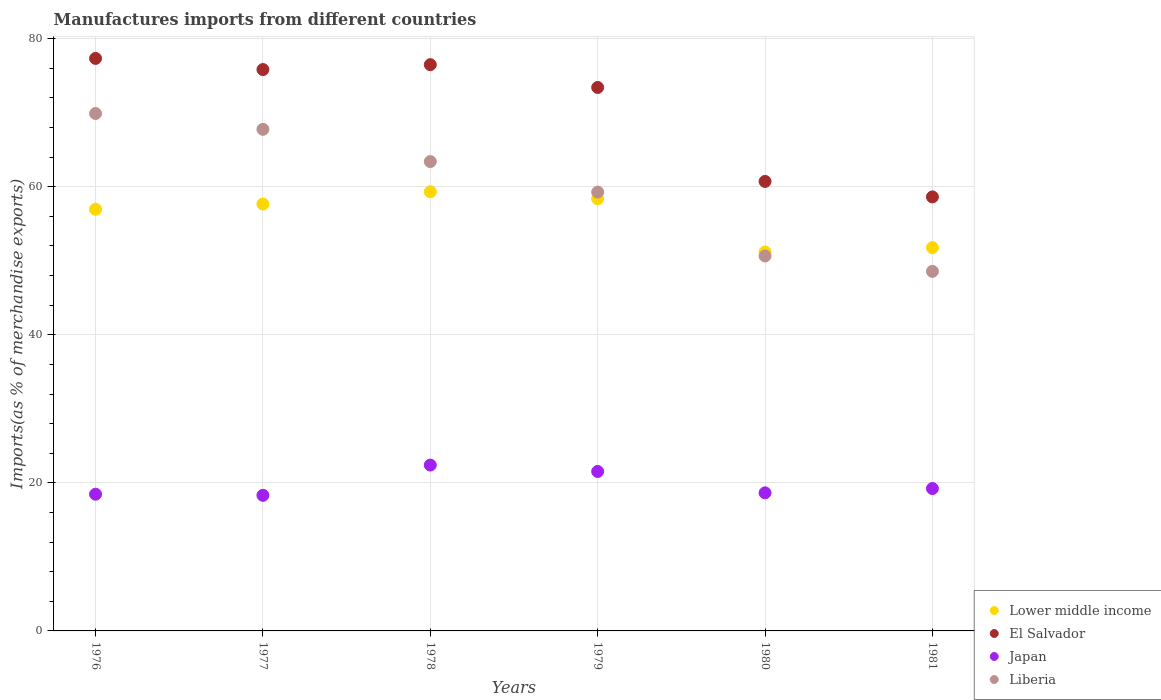How many different coloured dotlines are there?
Ensure brevity in your answer.  4. Is the number of dotlines equal to the number of legend labels?
Your response must be concise. Yes. What is the percentage of imports to different countries in Japan in 1979?
Your answer should be compact. 21.54. Across all years, what is the maximum percentage of imports to different countries in Lower middle income?
Your answer should be very brief. 59.32. Across all years, what is the minimum percentage of imports to different countries in Japan?
Provide a succinct answer. 18.32. In which year was the percentage of imports to different countries in Liberia maximum?
Make the answer very short. 1976. What is the total percentage of imports to different countries in Japan in the graph?
Offer a very short reply. 118.61. What is the difference between the percentage of imports to different countries in Japan in 1978 and that in 1981?
Provide a succinct answer. 3.17. What is the difference between the percentage of imports to different countries in El Salvador in 1981 and the percentage of imports to different countries in Liberia in 1976?
Your answer should be very brief. -11.27. What is the average percentage of imports to different countries in Lower middle income per year?
Ensure brevity in your answer.  55.88. In the year 1980, what is the difference between the percentage of imports to different countries in El Salvador and percentage of imports to different countries in Lower middle income?
Your answer should be very brief. 9.53. In how many years, is the percentage of imports to different countries in El Salvador greater than 36 %?
Keep it short and to the point. 6. What is the ratio of the percentage of imports to different countries in Lower middle income in 1976 to that in 1978?
Your response must be concise. 0.96. Is the percentage of imports to different countries in Liberia in 1979 less than that in 1981?
Offer a very short reply. No. What is the difference between the highest and the second highest percentage of imports to different countries in El Salvador?
Your answer should be compact. 0.84. What is the difference between the highest and the lowest percentage of imports to different countries in El Salvador?
Offer a very short reply. 18.71. Is the sum of the percentage of imports to different countries in Japan in 1976 and 1978 greater than the maximum percentage of imports to different countries in Lower middle income across all years?
Your answer should be very brief. No. Does the percentage of imports to different countries in El Salvador monotonically increase over the years?
Make the answer very short. No. How many dotlines are there?
Your answer should be very brief. 4. How many years are there in the graph?
Provide a short and direct response. 6. What is the difference between two consecutive major ticks on the Y-axis?
Provide a succinct answer. 20. Does the graph contain any zero values?
Provide a short and direct response. No. Where does the legend appear in the graph?
Give a very brief answer. Bottom right. How many legend labels are there?
Offer a very short reply. 4. How are the legend labels stacked?
Keep it short and to the point. Vertical. What is the title of the graph?
Your answer should be very brief. Manufactures imports from different countries. Does "St. Martin (French part)" appear as one of the legend labels in the graph?
Offer a very short reply. No. What is the label or title of the X-axis?
Offer a terse response. Years. What is the label or title of the Y-axis?
Your answer should be very brief. Imports(as % of merchandise exports). What is the Imports(as % of merchandise exports) of Lower middle income in 1976?
Your answer should be very brief. 56.96. What is the Imports(as % of merchandise exports) in El Salvador in 1976?
Make the answer very short. 77.33. What is the Imports(as % of merchandise exports) in Japan in 1976?
Keep it short and to the point. 18.47. What is the Imports(as % of merchandise exports) in Liberia in 1976?
Your answer should be very brief. 69.89. What is the Imports(as % of merchandise exports) of Lower middle income in 1977?
Your response must be concise. 57.66. What is the Imports(as % of merchandise exports) in El Salvador in 1977?
Your answer should be compact. 75.83. What is the Imports(as % of merchandise exports) in Japan in 1977?
Provide a succinct answer. 18.32. What is the Imports(as % of merchandise exports) in Liberia in 1977?
Your answer should be very brief. 67.76. What is the Imports(as % of merchandise exports) in Lower middle income in 1978?
Offer a very short reply. 59.32. What is the Imports(as % of merchandise exports) in El Salvador in 1978?
Provide a succinct answer. 76.49. What is the Imports(as % of merchandise exports) in Japan in 1978?
Provide a short and direct response. 22.4. What is the Imports(as % of merchandise exports) of Liberia in 1978?
Provide a succinct answer. 63.4. What is the Imports(as % of merchandise exports) in Lower middle income in 1979?
Keep it short and to the point. 58.38. What is the Imports(as % of merchandise exports) in El Salvador in 1979?
Provide a succinct answer. 73.41. What is the Imports(as % of merchandise exports) of Japan in 1979?
Provide a short and direct response. 21.54. What is the Imports(as % of merchandise exports) of Liberia in 1979?
Offer a very short reply. 59.27. What is the Imports(as % of merchandise exports) of Lower middle income in 1980?
Offer a terse response. 51.19. What is the Imports(as % of merchandise exports) in El Salvador in 1980?
Offer a very short reply. 60.72. What is the Imports(as % of merchandise exports) of Japan in 1980?
Make the answer very short. 18.65. What is the Imports(as % of merchandise exports) of Liberia in 1980?
Your answer should be very brief. 50.65. What is the Imports(as % of merchandise exports) in Lower middle income in 1981?
Offer a terse response. 51.77. What is the Imports(as % of merchandise exports) of El Salvador in 1981?
Offer a very short reply. 58.63. What is the Imports(as % of merchandise exports) in Japan in 1981?
Offer a very short reply. 19.23. What is the Imports(as % of merchandise exports) of Liberia in 1981?
Offer a terse response. 48.57. Across all years, what is the maximum Imports(as % of merchandise exports) of Lower middle income?
Provide a succinct answer. 59.32. Across all years, what is the maximum Imports(as % of merchandise exports) in El Salvador?
Make the answer very short. 77.33. Across all years, what is the maximum Imports(as % of merchandise exports) of Japan?
Your response must be concise. 22.4. Across all years, what is the maximum Imports(as % of merchandise exports) of Liberia?
Offer a terse response. 69.89. Across all years, what is the minimum Imports(as % of merchandise exports) in Lower middle income?
Provide a succinct answer. 51.19. Across all years, what is the minimum Imports(as % of merchandise exports) of El Salvador?
Your answer should be very brief. 58.63. Across all years, what is the minimum Imports(as % of merchandise exports) of Japan?
Your response must be concise. 18.32. Across all years, what is the minimum Imports(as % of merchandise exports) of Liberia?
Offer a very short reply. 48.57. What is the total Imports(as % of merchandise exports) in Lower middle income in the graph?
Offer a very short reply. 335.28. What is the total Imports(as % of merchandise exports) of El Salvador in the graph?
Your response must be concise. 422.4. What is the total Imports(as % of merchandise exports) of Japan in the graph?
Provide a short and direct response. 118.61. What is the total Imports(as % of merchandise exports) of Liberia in the graph?
Your answer should be compact. 359.54. What is the difference between the Imports(as % of merchandise exports) in Lower middle income in 1976 and that in 1977?
Make the answer very short. -0.7. What is the difference between the Imports(as % of merchandise exports) in El Salvador in 1976 and that in 1977?
Provide a short and direct response. 1.5. What is the difference between the Imports(as % of merchandise exports) of Japan in 1976 and that in 1977?
Keep it short and to the point. 0.15. What is the difference between the Imports(as % of merchandise exports) of Liberia in 1976 and that in 1977?
Your answer should be very brief. 2.14. What is the difference between the Imports(as % of merchandise exports) of Lower middle income in 1976 and that in 1978?
Make the answer very short. -2.36. What is the difference between the Imports(as % of merchandise exports) in El Salvador in 1976 and that in 1978?
Give a very brief answer. 0.84. What is the difference between the Imports(as % of merchandise exports) of Japan in 1976 and that in 1978?
Ensure brevity in your answer.  -3.94. What is the difference between the Imports(as % of merchandise exports) of Liberia in 1976 and that in 1978?
Ensure brevity in your answer.  6.49. What is the difference between the Imports(as % of merchandise exports) in Lower middle income in 1976 and that in 1979?
Keep it short and to the point. -1.42. What is the difference between the Imports(as % of merchandise exports) in El Salvador in 1976 and that in 1979?
Your response must be concise. 3.92. What is the difference between the Imports(as % of merchandise exports) of Japan in 1976 and that in 1979?
Offer a very short reply. -3.07. What is the difference between the Imports(as % of merchandise exports) in Liberia in 1976 and that in 1979?
Your answer should be very brief. 10.62. What is the difference between the Imports(as % of merchandise exports) of Lower middle income in 1976 and that in 1980?
Your response must be concise. 5.77. What is the difference between the Imports(as % of merchandise exports) of El Salvador in 1976 and that in 1980?
Ensure brevity in your answer.  16.62. What is the difference between the Imports(as % of merchandise exports) in Japan in 1976 and that in 1980?
Offer a terse response. -0.19. What is the difference between the Imports(as % of merchandise exports) in Liberia in 1976 and that in 1980?
Your answer should be very brief. 19.25. What is the difference between the Imports(as % of merchandise exports) of Lower middle income in 1976 and that in 1981?
Offer a terse response. 5.18. What is the difference between the Imports(as % of merchandise exports) in El Salvador in 1976 and that in 1981?
Offer a terse response. 18.71. What is the difference between the Imports(as % of merchandise exports) of Japan in 1976 and that in 1981?
Keep it short and to the point. -0.77. What is the difference between the Imports(as % of merchandise exports) of Liberia in 1976 and that in 1981?
Your answer should be very brief. 21.32. What is the difference between the Imports(as % of merchandise exports) of Lower middle income in 1977 and that in 1978?
Your answer should be very brief. -1.66. What is the difference between the Imports(as % of merchandise exports) of El Salvador in 1977 and that in 1978?
Your answer should be very brief. -0.66. What is the difference between the Imports(as % of merchandise exports) in Japan in 1977 and that in 1978?
Ensure brevity in your answer.  -4.09. What is the difference between the Imports(as % of merchandise exports) in Liberia in 1977 and that in 1978?
Your answer should be very brief. 4.35. What is the difference between the Imports(as % of merchandise exports) in Lower middle income in 1977 and that in 1979?
Ensure brevity in your answer.  -0.72. What is the difference between the Imports(as % of merchandise exports) in El Salvador in 1977 and that in 1979?
Provide a succinct answer. 2.42. What is the difference between the Imports(as % of merchandise exports) in Japan in 1977 and that in 1979?
Your answer should be very brief. -3.22. What is the difference between the Imports(as % of merchandise exports) in Liberia in 1977 and that in 1979?
Offer a very short reply. 8.48. What is the difference between the Imports(as % of merchandise exports) of Lower middle income in 1977 and that in 1980?
Provide a succinct answer. 6.48. What is the difference between the Imports(as % of merchandise exports) in El Salvador in 1977 and that in 1980?
Your response must be concise. 15.11. What is the difference between the Imports(as % of merchandise exports) of Japan in 1977 and that in 1980?
Your response must be concise. -0.34. What is the difference between the Imports(as % of merchandise exports) in Liberia in 1977 and that in 1980?
Your response must be concise. 17.11. What is the difference between the Imports(as % of merchandise exports) of Lower middle income in 1977 and that in 1981?
Give a very brief answer. 5.89. What is the difference between the Imports(as % of merchandise exports) in El Salvador in 1977 and that in 1981?
Provide a short and direct response. 17.2. What is the difference between the Imports(as % of merchandise exports) in Japan in 1977 and that in 1981?
Your answer should be very brief. -0.92. What is the difference between the Imports(as % of merchandise exports) in Liberia in 1977 and that in 1981?
Offer a very short reply. 19.19. What is the difference between the Imports(as % of merchandise exports) in Lower middle income in 1978 and that in 1979?
Offer a very short reply. 0.94. What is the difference between the Imports(as % of merchandise exports) in El Salvador in 1978 and that in 1979?
Keep it short and to the point. 3.08. What is the difference between the Imports(as % of merchandise exports) in Japan in 1978 and that in 1979?
Provide a succinct answer. 0.86. What is the difference between the Imports(as % of merchandise exports) in Liberia in 1978 and that in 1979?
Your answer should be compact. 4.13. What is the difference between the Imports(as % of merchandise exports) of Lower middle income in 1978 and that in 1980?
Keep it short and to the point. 8.13. What is the difference between the Imports(as % of merchandise exports) of El Salvador in 1978 and that in 1980?
Your answer should be compact. 15.77. What is the difference between the Imports(as % of merchandise exports) of Japan in 1978 and that in 1980?
Ensure brevity in your answer.  3.75. What is the difference between the Imports(as % of merchandise exports) in Liberia in 1978 and that in 1980?
Your answer should be compact. 12.76. What is the difference between the Imports(as % of merchandise exports) in Lower middle income in 1978 and that in 1981?
Ensure brevity in your answer.  7.55. What is the difference between the Imports(as % of merchandise exports) of El Salvador in 1978 and that in 1981?
Give a very brief answer. 17.86. What is the difference between the Imports(as % of merchandise exports) of Japan in 1978 and that in 1981?
Ensure brevity in your answer.  3.17. What is the difference between the Imports(as % of merchandise exports) in Liberia in 1978 and that in 1981?
Provide a short and direct response. 14.83. What is the difference between the Imports(as % of merchandise exports) of Lower middle income in 1979 and that in 1980?
Provide a short and direct response. 7.19. What is the difference between the Imports(as % of merchandise exports) in El Salvador in 1979 and that in 1980?
Your response must be concise. 12.69. What is the difference between the Imports(as % of merchandise exports) of Japan in 1979 and that in 1980?
Ensure brevity in your answer.  2.89. What is the difference between the Imports(as % of merchandise exports) of Liberia in 1979 and that in 1980?
Your response must be concise. 8.63. What is the difference between the Imports(as % of merchandise exports) in Lower middle income in 1979 and that in 1981?
Make the answer very short. 6.6. What is the difference between the Imports(as % of merchandise exports) of El Salvador in 1979 and that in 1981?
Offer a very short reply. 14.78. What is the difference between the Imports(as % of merchandise exports) in Japan in 1979 and that in 1981?
Make the answer very short. 2.31. What is the difference between the Imports(as % of merchandise exports) of Liberia in 1979 and that in 1981?
Make the answer very short. 10.7. What is the difference between the Imports(as % of merchandise exports) of Lower middle income in 1980 and that in 1981?
Provide a short and direct response. -0.59. What is the difference between the Imports(as % of merchandise exports) of El Salvador in 1980 and that in 1981?
Provide a short and direct response. 2.09. What is the difference between the Imports(as % of merchandise exports) in Japan in 1980 and that in 1981?
Ensure brevity in your answer.  -0.58. What is the difference between the Imports(as % of merchandise exports) of Liberia in 1980 and that in 1981?
Provide a succinct answer. 2.08. What is the difference between the Imports(as % of merchandise exports) of Lower middle income in 1976 and the Imports(as % of merchandise exports) of El Salvador in 1977?
Provide a short and direct response. -18.87. What is the difference between the Imports(as % of merchandise exports) in Lower middle income in 1976 and the Imports(as % of merchandise exports) in Japan in 1977?
Make the answer very short. 38.64. What is the difference between the Imports(as % of merchandise exports) in Lower middle income in 1976 and the Imports(as % of merchandise exports) in Liberia in 1977?
Ensure brevity in your answer.  -10.8. What is the difference between the Imports(as % of merchandise exports) of El Salvador in 1976 and the Imports(as % of merchandise exports) of Japan in 1977?
Keep it short and to the point. 59.02. What is the difference between the Imports(as % of merchandise exports) of El Salvador in 1976 and the Imports(as % of merchandise exports) of Liberia in 1977?
Ensure brevity in your answer.  9.58. What is the difference between the Imports(as % of merchandise exports) in Japan in 1976 and the Imports(as % of merchandise exports) in Liberia in 1977?
Ensure brevity in your answer.  -49.29. What is the difference between the Imports(as % of merchandise exports) of Lower middle income in 1976 and the Imports(as % of merchandise exports) of El Salvador in 1978?
Your response must be concise. -19.53. What is the difference between the Imports(as % of merchandise exports) in Lower middle income in 1976 and the Imports(as % of merchandise exports) in Japan in 1978?
Give a very brief answer. 34.56. What is the difference between the Imports(as % of merchandise exports) of Lower middle income in 1976 and the Imports(as % of merchandise exports) of Liberia in 1978?
Offer a terse response. -6.44. What is the difference between the Imports(as % of merchandise exports) of El Salvador in 1976 and the Imports(as % of merchandise exports) of Japan in 1978?
Your answer should be compact. 54.93. What is the difference between the Imports(as % of merchandise exports) of El Salvador in 1976 and the Imports(as % of merchandise exports) of Liberia in 1978?
Your answer should be compact. 13.93. What is the difference between the Imports(as % of merchandise exports) in Japan in 1976 and the Imports(as % of merchandise exports) in Liberia in 1978?
Your response must be concise. -44.94. What is the difference between the Imports(as % of merchandise exports) in Lower middle income in 1976 and the Imports(as % of merchandise exports) in El Salvador in 1979?
Give a very brief answer. -16.45. What is the difference between the Imports(as % of merchandise exports) in Lower middle income in 1976 and the Imports(as % of merchandise exports) in Japan in 1979?
Your answer should be compact. 35.42. What is the difference between the Imports(as % of merchandise exports) in Lower middle income in 1976 and the Imports(as % of merchandise exports) in Liberia in 1979?
Your answer should be very brief. -2.31. What is the difference between the Imports(as % of merchandise exports) in El Salvador in 1976 and the Imports(as % of merchandise exports) in Japan in 1979?
Provide a succinct answer. 55.79. What is the difference between the Imports(as % of merchandise exports) of El Salvador in 1976 and the Imports(as % of merchandise exports) of Liberia in 1979?
Keep it short and to the point. 18.06. What is the difference between the Imports(as % of merchandise exports) of Japan in 1976 and the Imports(as % of merchandise exports) of Liberia in 1979?
Offer a terse response. -40.81. What is the difference between the Imports(as % of merchandise exports) in Lower middle income in 1976 and the Imports(as % of merchandise exports) in El Salvador in 1980?
Offer a very short reply. -3.76. What is the difference between the Imports(as % of merchandise exports) of Lower middle income in 1976 and the Imports(as % of merchandise exports) of Japan in 1980?
Ensure brevity in your answer.  38.31. What is the difference between the Imports(as % of merchandise exports) of Lower middle income in 1976 and the Imports(as % of merchandise exports) of Liberia in 1980?
Your answer should be very brief. 6.31. What is the difference between the Imports(as % of merchandise exports) in El Salvador in 1976 and the Imports(as % of merchandise exports) in Japan in 1980?
Your answer should be very brief. 58.68. What is the difference between the Imports(as % of merchandise exports) of El Salvador in 1976 and the Imports(as % of merchandise exports) of Liberia in 1980?
Your answer should be very brief. 26.69. What is the difference between the Imports(as % of merchandise exports) of Japan in 1976 and the Imports(as % of merchandise exports) of Liberia in 1980?
Keep it short and to the point. -32.18. What is the difference between the Imports(as % of merchandise exports) of Lower middle income in 1976 and the Imports(as % of merchandise exports) of El Salvador in 1981?
Give a very brief answer. -1.67. What is the difference between the Imports(as % of merchandise exports) in Lower middle income in 1976 and the Imports(as % of merchandise exports) in Japan in 1981?
Keep it short and to the point. 37.73. What is the difference between the Imports(as % of merchandise exports) in Lower middle income in 1976 and the Imports(as % of merchandise exports) in Liberia in 1981?
Keep it short and to the point. 8.39. What is the difference between the Imports(as % of merchandise exports) in El Salvador in 1976 and the Imports(as % of merchandise exports) in Japan in 1981?
Provide a succinct answer. 58.1. What is the difference between the Imports(as % of merchandise exports) in El Salvador in 1976 and the Imports(as % of merchandise exports) in Liberia in 1981?
Keep it short and to the point. 28.76. What is the difference between the Imports(as % of merchandise exports) of Japan in 1976 and the Imports(as % of merchandise exports) of Liberia in 1981?
Your answer should be very brief. -30.1. What is the difference between the Imports(as % of merchandise exports) of Lower middle income in 1977 and the Imports(as % of merchandise exports) of El Salvador in 1978?
Give a very brief answer. -18.83. What is the difference between the Imports(as % of merchandise exports) of Lower middle income in 1977 and the Imports(as % of merchandise exports) of Japan in 1978?
Ensure brevity in your answer.  35.26. What is the difference between the Imports(as % of merchandise exports) in Lower middle income in 1977 and the Imports(as % of merchandise exports) in Liberia in 1978?
Provide a short and direct response. -5.74. What is the difference between the Imports(as % of merchandise exports) in El Salvador in 1977 and the Imports(as % of merchandise exports) in Japan in 1978?
Provide a short and direct response. 53.43. What is the difference between the Imports(as % of merchandise exports) in El Salvador in 1977 and the Imports(as % of merchandise exports) in Liberia in 1978?
Offer a very short reply. 12.43. What is the difference between the Imports(as % of merchandise exports) of Japan in 1977 and the Imports(as % of merchandise exports) of Liberia in 1978?
Your response must be concise. -45.09. What is the difference between the Imports(as % of merchandise exports) in Lower middle income in 1977 and the Imports(as % of merchandise exports) in El Salvador in 1979?
Your answer should be compact. -15.75. What is the difference between the Imports(as % of merchandise exports) in Lower middle income in 1977 and the Imports(as % of merchandise exports) in Japan in 1979?
Ensure brevity in your answer.  36.12. What is the difference between the Imports(as % of merchandise exports) in Lower middle income in 1977 and the Imports(as % of merchandise exports) in Liberia in 1979?
Give a very brief answer. -1.61. What is the difference between the Imports(as % of merchandise exports) in El Salvador in 1977 and the Imports(as % of merchandise exports) in Japan in 1979?
Your response must be concise. 54.29. What is the difference between the Imports(as % of merchandise exports) in El Salvador in 1977 and the Imports(as % of merchandise exports) in Liberia in 1979?
Make the answer very short. 16.56. What is the difference between the Imports(as % of merchandise exports) in Japan in 1977 and the Imports(as % of merchandise exports) in Liberia in 1979?
Keep it short and to the point. -40.96. What is the difference between the Imports(as % of merchandise exports) of Lower middle income in 1977 and the Imports(as % of merchandise exports) of El Salvador in 1980?
Give a very brief answer. -3.05. What is the difference between the Imports(as % of merchandise exports) of Lower middle income in 1977 and the Imports(as % of merchandise exports) of Japan in 1980?
Provide a short and direct response. 39.01. What is the difference between the Imports(as % of merchandise exports) in Lower middle income in 1977 and the Imports(as % of merchandise exports) in Liberia in 1980?
Provide a short and direct response. 7.02. What is the difference between the Imports(as % of merchandise exports) in El Salvador in 1977 and the Imports(as % of merchandise exports) in Japan in 1980?
Your answer should be compact. 57.18. What is the difference between the Imports(as % of merchandise exports) in El Salvador in 1977 and the Imports(as % of merchandise exports) in Liberia in 1980?
Ensure brevity in your answer.  25.18. What is the difference between the Imports(as % of merchandise exports) of Japan in 1977 and the Imports(as % of merchandise exports) of Liberia in 1980?
Ensure brevity in your answer.  -32.33. What is the difference between the Imports(as % of merchandise exports) in Lower middle income in 1977 and the Imports(as % of merchandise exports) in El Salvador in 1981?
Make the answer very short. -0.96. What is the difference between the Imports(as % of merchandise exports) of Lower middle income in 1977 and the Imports(as % of merchandise exports) of Japan in 1981?
Keep it short and to the point. 38.43. What is the difference between the Imports(as % of merchandise exports) of Lower middle income in 1977 and the Imports(as % of merchandise exports) of Liberia in 1981?
Give a very brief answer. 9.09. What is the difference between the Imports(as % of merchandise exports) in El Salvador in 1977 and the Imports(as % of merchandise exports) in Japan in 1981?
Make the answer very short. 56.6. What is the difference between the Imports(as % of merchandise exports) in El Salvador in 1977 and the Imports(as % of merchandise exports) in Liberia in 1981?
Make the answer very short. 27.26. What is the difference between the Imports(as % of merchandise exports) in Japan in 1977 and the Imports(as % of merchandise exports) in Liberia in 1981?
Your answer should be very brief. -30.25. What is the difference between the Imports(as % of merchandise exports) in Lower middle income in 1978 and the Imports(as % of merchandise exports) in El Salvador in 1979?
Give a very brief answer. -14.09. What is the difference between the Imports(as % of merchandise exports) of Lower middle income in 1978 and the Imports(as % of merchandise exports) of Japan in 1979?
Your answer should be compact. 37.78. What is the difference between the Imports(as % of merchandise exports) of Lower middle income in 1978 and the Imports(as % of merchandise exports) of Liberia in 1979?
Provide a succinct answer. 0.05. What is the difference between the Imports(as % of merchandise exports) in El Salvador in 1978 and the Imports(as % of merchandise exports) in Japan in 1979?
Give a very brief answer. 54.95. What is the difference between the Imports(as % of merchandise exports) of El Salvador in 1978 and the Imports(as % of merchandise exports) of Liberia in 1979?
Ensure brevity in your answer.  17.22. What is the difference between the Imports(as % of merchandise exports) in Japan in 1978 and the Imports(as % of merchandise exports) in Liberia in 1979?
Give a very brief answer. -36.87. What is the difference between the Imports(as % of merchandise exports) in Lower middle income in 1978 and the Imports(as % of merchandise exports) in El Salvador in 1980?
Your response must be concise. -1.4. What is the difference between the Imports(as % of merchandise exports) of Lower middle income in 1978 and the Imports(as % of merchandise exports) of Japan in 1980?
Offer a terse response. 40.67. What is the difference between the Imports(as % of merchandise exports) in Lower middle income in 1978 and the Imports(as % of merchandise exports) in Liberia in 1980?
Your response must be concise. 8.67. What is the difference between the Imports(as % of merchandise exports) of El Salvador in 1978 and the Imports(as % of merchandise exports) of Japan in 1980?
Your answer should be very brief. 57.84. What is the difference between the Imports(as % of merchandise exports) in El Salvador in 1978 and the Imports(as % of merchandise exports) in Liberia in 1980?
Offer a very short reply. 25.84. What is the difference between the Imports(as % of merchandise exports) in Japan in 1978 and the Imports(as % of merchandise exports) in Liberia in 1980?
Keep it short and to the point. -28.24. What is the difference between the Imports(as % of merchandise exports) of Lower middle income in 1978 and the Imports(as % of merchandise exports) of El Salvador in 1981?
Your response must be concise. 0.69. What is the difference between the Imports(as % of merchandise exports) in Lower middle income in 1978 and the Imports(as % of merchandise exports) in Japan in 1981?
Offer a very short reply. 40.09. What is the difference between the Imports(as % of merchandise exports) in Lower middle income in 1978 and the Imports(as % of merchandise exports) in Liberia in 1981?
Offer a very short reply. 10.75. What is the difference between the Imports(as % of merchandise exports) of El Salvador in 1978 and the Imports(as % of merchandise exports) of Japan in 1981?
Your response must be concise. 57.26. What is the difference between the Imports(as % of merchandise exports) of El Salvador in 1978 and the Imports(as % of merchandise exports) of Liberia in 1981?
Keep it short and to the point. 27.92. What is the difference between the Imports(as % of merchandise exports) of Japan in 1978 and the Imports(as % of merchandise exports) of Liberia in 1981?
Provide a succinct answer. -26.17. What is the difference between the Imports(as % of merchandise exports) in Lower middle income in 1979 and the Imports(as % of merchandise exports) in El Salvador in 1980?
Your answer should be very brief. -2.34. What is the difference between the Imports(as % of merchandise exports) in Lower middle income in 1979 and the Imports(as % of merchandise exports) in Japan in 1980?
Offer a very short reply. 39.73. What is the difference between the Imports(as % of merchandise exports) of Lower middle income in 1979 and the Imports(as % of merchandise exports) of Liberia in 1980?
Provide a short and direct response. 7.73. What is the difference between the Imports(as % of merchandise exports) of El Salvador in 1979 and the Imports(as % of merchandise exports) of Japan in 1980?
Your answer should be compact. 54.76. What is the difference between the Imports(as % of merchandise exports) of El Salvador in 1979 and the Imports(as % of merchandise exports) of Liberia in 1980?
Offer a very short reply. 22.76. What is the difference between the Imports(as % of merchandise exports) of Japan in 1979 and the Imports(as % of merchandise exports) of Liberia in 1980?
Keep it short and to the point. -29.11. What is the difference between the Imports(as % of merchandise exports) of Lower middle income in 1979 and the Imports(as % of merchandise exports) of El Salvador in 1981?
Offer a very short reply. -0.25. What is the difference between the Imports(as % of merchandise exports) of Lower middle income in 1979 and the Imports(as % of merchandise exports) of Japan in 1981?
Provide a short and direct response. 39.15. What is the difference between the Imports(as % of merchandise exports) in Lower middle income in 1979 and the Imports(as % of merchandise exports) in Liberia in 1981?
Offer a very short reply. 9.81. What is the difference between the Imports(as % of merchandise exports) in El Salvador in 1979 and the Imports(as % of merchandise exports) in Japan in 1981?
Your answer should be very brief. 54.18. What is the difference between the Imports(as % of merchandise exports) in El Salvador in 1979 and the Imports(as % of merchandise exports) in Liberia in 1981?
Make the answer very short. 24.84. What is the difference between the Imports(as % of merchandise exports) of Japan in 1979 and the Imports(as % of merchandise exports) of Liberia in 1981?
Offer a very short reply. -27.03. What is the difference between the Imports(as % of merchandise exports) of Lower middle income in 1980 and the Imports(as % of merchandise exports) of El Salvador in 1981?
Offer a terse response. -7.44. What is the difference between the Imports(as % of merchandise exports) in Lower middle income in 1980 and the Imports(as % of merchandise exports) in Japan in 1981?
Provide a short and direct response. 31.95. What is the difference between the Imports(as % of merchandise exports) in Lower middle income in 1980 and the Imports(as % of merchandise exports) in Liberia in 1981?
Offer a terse response. 2.62. What is the difference between the Imports(as % of merchandise exports) of El Salvador in 1980 and the Imports(as % of merchandise exports) of Japan in 1981?
Make the answer very short. 41.48. What is the difference between the Imports(as % of merchandise exports) of El Salvador in 1980 and the Imports(as % of merchandise exports) of Liberia in 1981?
Provide a short and direct response. 12.15. What is the difference between the Imports(as % of merchandise exports) in Japan in 1980 and the Imports(as % of merchandise exports) in Liberia in 1981?
Offer a very short reply. -29.92. What is the average Imports(as % of merchandise exports) in Lower middle income per year?
Provide a succinct answer. 55.88. What is the average Imports(as % of merchandise exports) in El Salvador per year?
Ensure brevity in your answer.  70.4. What is the average Imports(as % of merchandise exports) of Japan per year?
Provide a short and direct response. 19.77. What is the average Imports(as % of merchandise exports) of Liberia per year?
Offer a terse response. 59.92. In the year 1976, what is the difference between the Imports(as % of merchandise exports) of Lower middle income and Imports(as % of merchandise exports) of El Salvador?
Offer a very short reply. -20.37. In the year 1976, what is the difference between the Imports(as % of merchandise exports) in Lower middle income and Imports(as % of merchandise exports) in Japan?
Make the answer very short. 38.49. In the year 1976, what is the difference between the Imports(as % of merchandise exports) of Lower middle income and Imports(as % of merchandise exports) of Liberia?
Your answer should be compact. -12.93. In the year 1976, what is the difference between the Imports(as % of merchandise exports) of El Salvador and Imports(as % of merchandise exports) of Japan?
Your answer should be compact. 58.87. In the year 1976, what is the difference between the Imports(as % of merchandise exports) in El Salvador and Imports(as % of merchandise exports) in Liberia?
Ensure brevity in your answer.  7.44. In the year 1976, what is the difference between the Imports(as % of merchandise exports) in Japan and Imports(as % of merchandise exports) in Liberia?
Keep it short and to the point. -51.43. In the year 1977, what is the difference between the Imports(as % of merchandise exports) of Lower middle income and Imports(as % of merchandise exports) of El Salvador?
Offer a terse response. -18.17. In the year 1977, what is the difference between the Imports(as % of merchandise exports) in Lower middle income and Imports(as % of merchandise exports) in Japan?
Provide a short and direct response. 39.35. In the year 1977, what is the difference between the Imports(as % of merchandise exports) of Lower middle income and Imports(as % of merchandise exports) of Liberia?
Provide a short and direct response. -10.09. In the year 1977, what is the difference between the Imports(as % of merchandise exports) in El Salvador and Imports(as % of merchandise exports) in Japan?
Offer a terse response. 57.51. In the year 1977, what is the difference between the Imports(as % of merchandise exports) in El Salvador and Imports(as % of merchandise exports) in Liberia?
Offer a terse response. 8.07. In the year 1977, what is the difference between the Imports(as % of merchandise exports) in Japan and Imports(as % of merchandise exports) in Liberia?
Your answer should be compact. -49.44. In the year 1978, what is the difference between the Imports(as % of merchandise exports) of Lower middle income and Imports(as % of merchandise exports) of El Salvador?
Your answer should be compact. -17.17. In the year 1978, what is the difference between the Imports(as % of merchandise exports) in Lower middle income and Imports(as % of merchandise exports) in Japan?
Give a very brief answer. 36.92. In the year 1978, what is the difference between the Imports(as % of merchandise exports) of Lower middle income and Imports(as % of merchandise exports) of Liberia?
Give a very brief answer. -4.08. In the year 1978, what is the difference between the Imports(as % of merchandise exports) in El Salvador and Imports(as % of merchandise exports) in Japan?
Offer a very short reply. 54.09. In the year 1978, what is the difference between the Imports(as % of merchandise exports) of El Salvador and Imports(as % of merchandise exports) of Liberia?
Ensure brevity in your answer.  13.09. In the year 1978, what is the difference between the Imports(as % of merchandise exports) in Japan and Imports(as % of merchandise exports) in Liberia?
Give a very brief answer. -41. In the year 1979, what is the difference between the Imports(as % of merchandise exports) of Lower middle income and Imports(as % of merchandise exports) of El Salvador?
Offer a terse response. -15.03. In the year 1979, what is the difference between the Imports(as % of merchandise exports) in Lower middle income and Imports(as % of merchandise exports) in Japan?
Provide a short and direct response. 36.84. In the year 1979, what is the difference between the Imports(as % of merchandise exports) in Lower middle income and Imports(as % of merchandise exports) in Liberia?
Your answer should be compact. -0.89. In the year 1979, what is the difference between the Imports(as % of merchandise exports) in El Salvador and Imports(as % of merchandise exports) in Japan?
Give a very brief answer. 51.87. In the year 1979, what is the difference between the Imports(as % of merchandise exports) in El Salvador and Imports(as % of merchandise exports) in Liberia?
Provide a succinct answer. 14.14. In the year 1979, what is the difference between the Imports(as % of merchandise exports) of Japan and Imports(as % of merchandise exports) of Liberia?
Offer a very short reply. -37.73. In the year 1980, what is the difference between the Imports(as % of merchandise exports) of Lower middle income and Imports(as % of merchandise exports) of El Salvador?
Ensure brevity in your answer.  -9.53. In the year 1980, what is the difference between the Imports(as % of merchandise exports) of Lower middle income and Imports(as % of merchandise exports) of Japan?
Provide a short and direct response. 32.53. In the year 1980, what is the difference between the Imports(as % of merchandise exports) in Lower middle income and Imports(as % of merchandise exports) in Liberia?
Your response must be concise. 0.54. In the year 1980, what is the difference between the Imports(as % of merchandise exports) in El Salvador and Imports(as % of merchandise exports) in Japan?
Ensure brevity in your answer.  42.07. In the year 1980, what is the difference between the Imports(as % of merchandise exports) in El Salvador and Imports(as % of merchandise exports) in Liberia?
Keep it short and to the point. 10.07. In the year 1980, what is the difference between the Imports(as % of merchandise exports) in Japan and Imports(as % of merchandise exports) in Liberia?
Provide a succinct answer. -31.99. In the year 1981, what is the difference between the Imports(as % of merchandise exports) of Lower middle income and Imports(as % of merchandise exports) of El Salvador?
Your response must be concise. -6.85. In the year 1981, what is the difference between the Imports(as % of merchandise exports) in Lower middle income and Imports(as % of merchandise exports) in Japan?
Your answer should be compact. 32.54. In the year 1981, what is the difference between the Imports(as % of merchandise exports) of Lower middle income and Imports(as % of merchandise exports) of Liberia?
Provide a succinct answer. 3.21. In the year 1981, what is the difference between the Imports(as % of merchandise exports) in El Salvador and Imports(as % of merchandise exports) in Japan?
Your answer should be compact. 39.39. In the year 1981, what is the difference between the Imports(as % of merchandise exports) in El Salvador and Imports(as % of merchandise exports) in Liberia?
Offer a terse response. 10.06. In the year 1981, what is the difference between the Imports(as % of merchandise exports) in Japan and Imports(as % of merchandise exports) in Liberia?
Provide a short and direct response. -29.34. What is the ratio of the Imports(as % of merchandise exports) of Lower middle income in 1976 to that in 1977?
Give a very brief answer. 0.99. What is the ratio of the Imports(as % of merchandise exports) in El Salvador in 1976 to that in 1977?
Provide a short and direct response. 1.02. What is the ratio of the Imports(as % of merchandise exports) in Japan in 1976 to that in 1977?
Your response must be concise. 1.01. What is the ratio of the Imports(as % of merchandise exports) of Liberia in 1976 to that in 1977?
Offer a terse response. 1.03. What is the ratio of the Imports(as % of merchandise exports) of Lower middle income in 1976 to that in 1978?
Offer a very short reply. 0.96. What is the ratio of the Imports(as % of merchandise exports) of El Salvador in 1976 to that in 1978?
Give a very brief answer. 1.01. What is the ratio of the Imports(as % of merchandise exports) in Japan in 1976 to that in 1978?
Offer a terse response. 0.82. What is the ratio of the Imports(as % of merchandise exports) of Liberia in 1976 to that in 1978?
Ensure brevity in your answer.  1.1. What is the ratio of the Imports(as % of merchandise exports) in Lower middle income in 1976 to that in 1979?
Make the answer very short. 0.98. What is the ratio of the Imports(as % of merchandise exports) in El Salvador in 1976 to that in 1979?
Provide a short and direct response. 1.05. What is the ratio of the Imports(as % of merchandise exports) of Japan in 1976 to that in 1979?
Give a very brief answer. 0.86. What is the ratio of the Imports(as % of merchandise exports) of Liberia in 1976 to that in 1979?
Provide a short and direct response. 1.18. What is the ratio of the Imports(as % of merchandise exports) in Lower middle income in 1976 to that in 1980?
Ensure brevity in your answer.  1.11. What is the ratio of the Imports(as % of merchandise exports) in El Salvador in 1976 to that in 1980?
Keep it short and to the point. 1.27. What is the ratio of the Imports(as % of merchandise exports) in Japan in 1976 to that in 1980?
Your answer should be compact. 0.99. What is the ratio of the Imports(as % of merchandise exports) of Liberia in 1976 to that in 1980?
Keep it short and to the point. 1.38. What is the ratio of the Imports(as % of merchandise exports) in Lower middle income in 1976 to that in 1981?
Offer a very short reply. 1.1. What is the ratio of the Imports(as % of merchandise exports) in El Salvador in 1976 to that in 1981?
Ensure brevity in your answer.  1.32. What is the ratio of the Imports(as % of merchandise exports) in Japan in 1976 to that in 1981?
Ensure brevity in your answer.  0.96. What is the ratio of the Imports(as % of merchandise exports) of Liberia in 1976 to that in 1981?
Ensure brevity in your answer.  1.44. What is the ratio of the Imports(as % of merchandise exports) in Lower middle income in 1977 to that in 1978?
Your answer should be compact. 0.97. What is the ratio of the Imports(as % of merchandise exports) in Japan in 1977 to that in 1978?
Your answer should be very brief. 0.82. What is the ratio of the Imports(as % of merchandise exports) of Liberia in 1977 to that in 1978?
Provide a short and direct response. 1.07. What is the ratio of the Imports(as % of merchandise exports) in Lower middle income in 1977 to that in 1979?
Provide a succinct answer. 0.99. What is the ratio of the Imports(as % of merchandise exports) in El Salvador in 1977 to that in 1979?
Give a very brief answer. 1.03. What is the ratio of the Imports(as % of merchandise exports) of Japan in 1977 to that in 1979?
Your answer should be compact. 0.85. What is the ratio of the Imports(as % of merchandise exports) in Liberia in 1977 to that in 1979?
Give a very brief answer. 1.14. What is the ratio of the Imports(as % of merchandise exports) of Lower middle income in 1977 to that in 1980?
Keep it short and to the point. 1.13. What is the ratio of the Imports(as % of merchandise exports) in El Salvador in 1977 to that in 1980?
Your response must be concise. 1.25. What is the ratio of the Imports(as % of merchandise exports) in Liberia in 1977 to that in 1980?
Make the answer very short. 1.34. What is the ratio of the Imports(as % of merchandise exports) of Lower middle income in 1977 to that in 1981?
Your response must be concise. 1.11. What is the ratio of the Imports(as % of merchandise exports) in El Salvador in 1977 to that in 1981?
Give a very brief answer. 1.29. What is the ratio of the Imports(as % of merchandise exports) of Japan in 1977 to that in 1981?
Offer a terse response. 0.95. What is the ratio of the Imports(as % of merchandise exports) of Liberia in 1977 to that in 1981?
Offer a very short reply. 1.4. What is the ratio of the Imports(as % of merchandise exports) in Lower middle income in 1978 to that in 1979?
Provide a short and direct response. 1.02. What is the ratio of the Imports(as % of merchandise exports) of El Salvador in 1978 to that in 1979?
Make the answer very short. 1.04. What is the ratio of the Imports(as % of merchandise exports) of Japan in 1978 to that in 1979?
Give a very brief answer. 1.04. What is the ratio of the Imports(as % of merchandise exports) of Liberia in 1978 to that in 1979?
Give a very brief answer. 1.07. What is the ratio of the Imports(as % of merchandise exports) in Lower middle income in 1978 to that in 1980?
Your answer should be compact. 1.16. What is the ratio of the Imports(as % of merchandise exports) of El Salvador in 1978 to that in 1980?
Offer a very short reply. 1.26. What is the ratio of the Imports(as % of merchandise exports) of Japan in 1978 to that in 1980?
Give a very brief answer. 1.2. What is the ratio of the Imports(as % of merchandise exports) of Liberia in 1978 to that in 1980?
Provide a succinct answer. 1.25. What is the ratio of the Imports(as % of merchandise exports) in Lower middle income in 1978 to that in 1981?
Your answer should be very brief. 1.15. What is the ratio of the Imports(as % of merchandise exports) in El Salvador in 1978 to that in 1981?
Offer a very short reply. 1.3. What is the ratio of the Imports(as % of merchandise exports) of Japan in 1978 to that in 1981?
Ensure brevity in your answer.  1.16. What is the ratio of the Imports(as % of merchandise exports) of Liberia in 1978 to that in 1981?
Provide a succinct answer. 1.31. What is the ratio of the Imports(as % of merchandise exports) in Lower middle income in 1979 to that in 1980?
Keep it short and to the point. 1.14. What is the ratio of the Imports(as % of merchandise exports) of El Salvador in 1979 to that in 1980?
Provide a short and direct response. 1.21. What is the ratio of the Imports(as % of merchandise exports) in Japan in 1979 to that in 1980?
Offer a very short reply. 1.15. What is the ratio of the Imports(as % of merchandise exports) of Liberia in 1979 to that in 1980?
Provide a short and direct response. 1.17. What is the ratio of the Imports(as % of merchandise exports) of Lower middle income in 1979 to that in 1981?
Keep it short and to the point. 1.13. What is the ratio of the Imports(as % of merchandise exports) of El Salvador in 1979 to that in 1981?
Give a very brief answer. 1.25. What is the ratio of the Imports(as % of merchandise exports) of Japan in 1979 to that in 1981?
Offer a terse response. 1.12. What is the ratio of the Imports(as % of merchandise exports) of Liberia in 1979 to that in 1981?
Your response must be concise. 1.22. What is the ratio of the Imports(as % of merchandise exports) of Lower middle income in 1980 to that in 1981?
Offer a terse response. 0.99. What is the ratio of the Imports(as % of merchandise exports) of El Salvador in 1980 to that in 1981?
Give a very brief answer. 1.04. What is the ratio of the Imports(as % of merchandise exports) in Japan in 1980 to that in 1981?
Give a very brief answer. 0.97. What is the ratio of the Imports(as % of merchandise exports) in Liberia in 1980 to that in 1981?
Make the answer very short. 1.04. What is the difference between the highest and the second highest Imports(as % of merchandise exports) of Lower middle income?
Make the answer very short. 0.94. What is the difference between the highest and the second highest Imports(as % of merchandise exports) in El Salvador?
Offer a terse response. 0.84. What is the difference between the highest and the second highest Imports(as % of merchandise exports) of Japan?
Provide a short and direct response. 0.86. What is the difference between the highest and the second highest Imports(as % of merchandise exports) in Liberia?
Your answer should be very brief. 2.14. What is the difference between the highest and the lowest Imports(as % of merchandise exports) of Lower middle income?
Your answer should be compact. 8.13. What is the difference between the highest and the lowest Imports(as % of merchandise exports) in El Salvador?
Provide a succinct answer. 18.71. What is the difference between the highest and the lowest Imports(as % of merchandise exports) of Japan?
Your answer should be very brief. 4.09. What is the difference between the highest and the lowest Imports(as % of merchandise exports) of Liberia?
Keep it short and to the point. 21.32. 